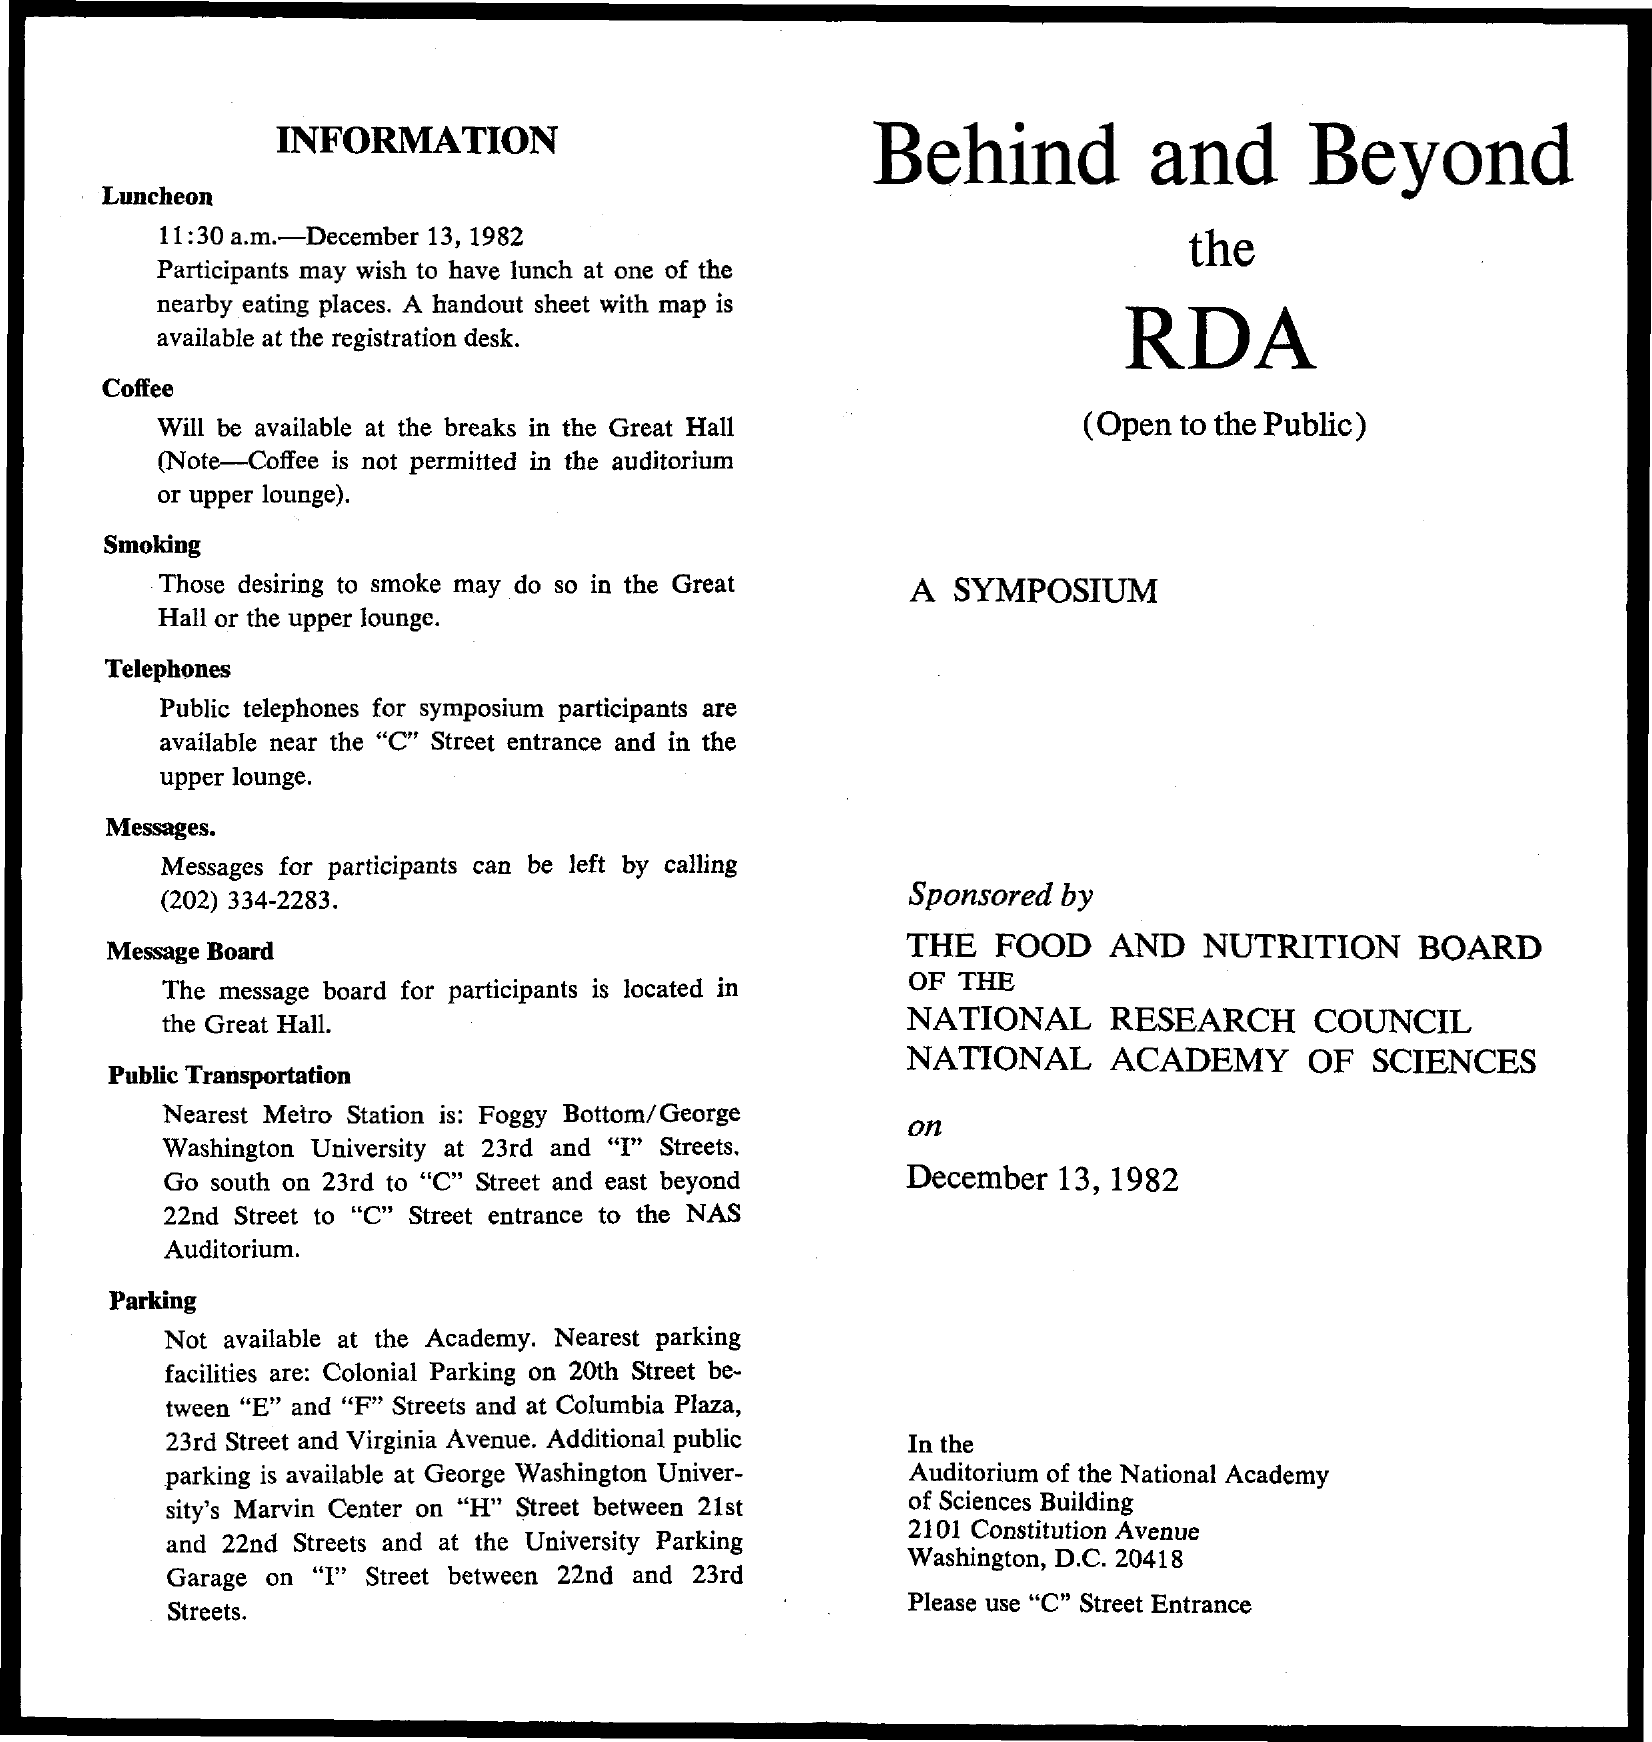What is the date mentioned ?
Offer a terse response. December 13, 1982. 